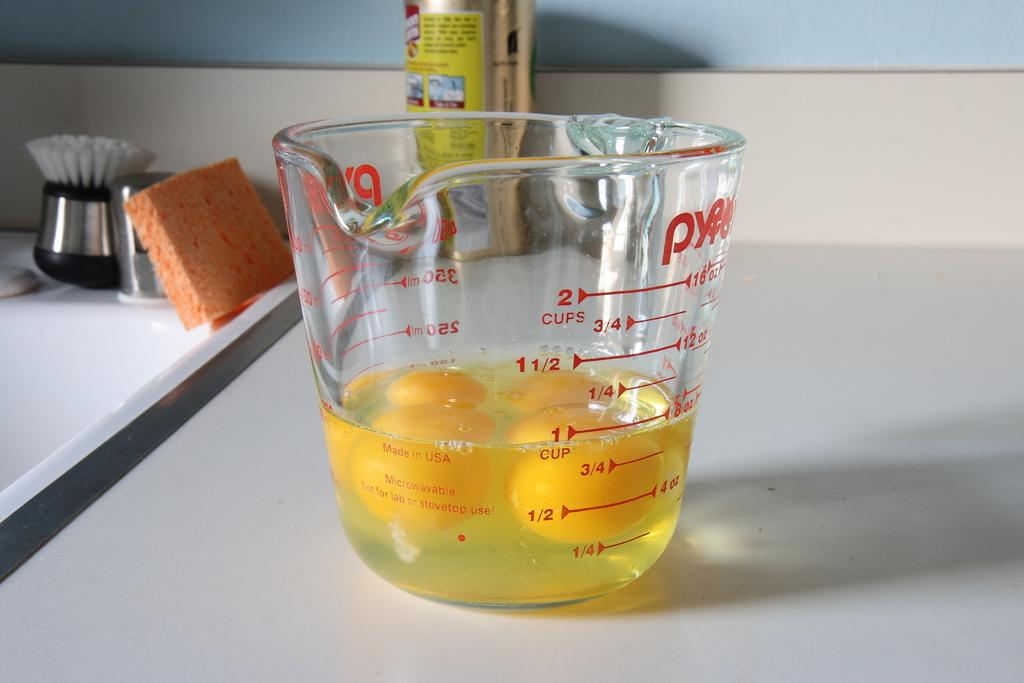<image>
Offer a succinct explanation of the picture presented. a measuring cup with 4 egg yolks on the counter 